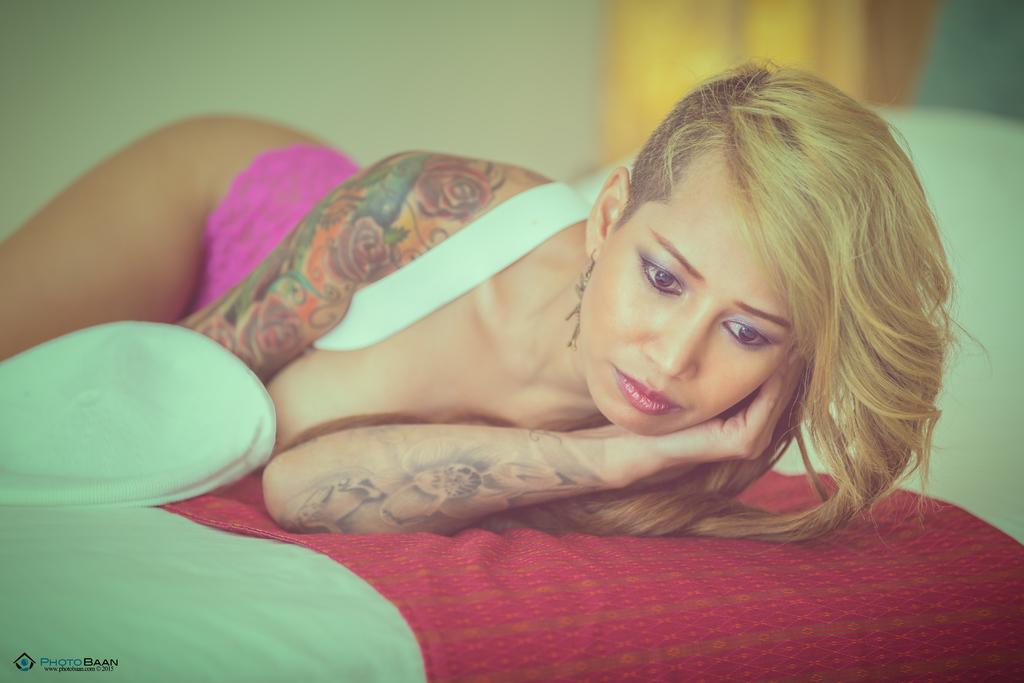Who is the main subject in the image? There is a woman in the image. What is the woman doing in the image? The woman is laying on a bed. What is covering the bed in the image? There is a bed sheet on the bed. Can you describe the background of the image? The background of the image is blurry. What type of swing can be seen in the background of the image? There is no swing present in the image; the background is blurry. 